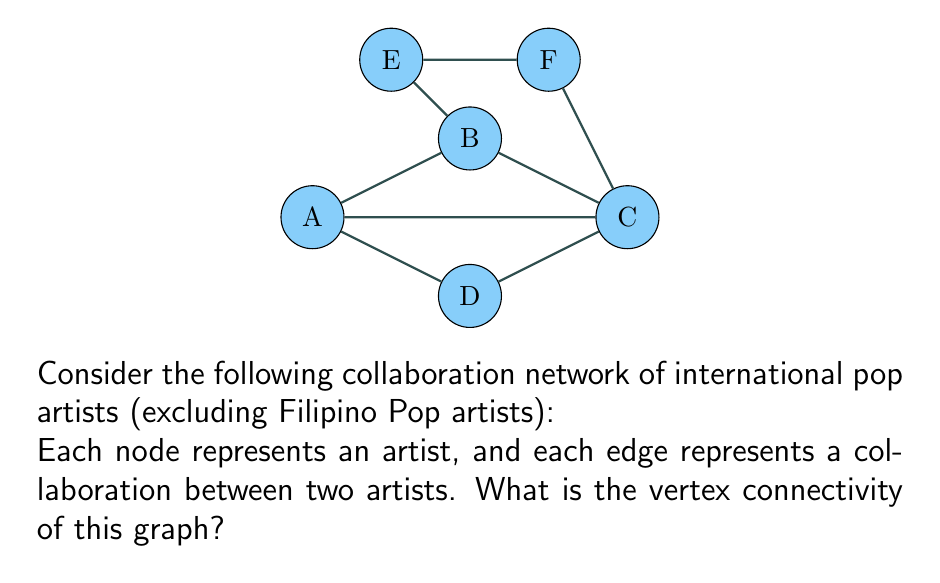Show me your answer to this math problem. To find the vertex connectivity of the graph, we need to determine the minimum number of vertices that need to be removed to disconnect the graph or reduce it to a single vertex.

Step 1: Analyze the graph structure
- The graph has 6 vertices (A, B, C, D, E, F)
- It forms a cycle A-B-C-D-A with additional connections B-E, E-F, F-C, and A-C

Step 2: Consider potential cut-sets
- Removing any single vertex does not disconnect the graph
- Removing vertices B and C disconnects the graph into three components: {A,D}, {E}, and {F}

Step 3: Verify that there is no smaller cut-set
- Removing any single vertex leaves the graph connected
- Any pair of vertices other than B and C does not disconnect the graph as much

Step 4: Define vertex connectivity
The vertex connectivity of a graph, denoted as $\kappa(G)$, is the minimum number of vertices whose removal results in a disconnected graph or a graph with only one vertex.

Step 5: Conclude
Since removing 2 vertices (B and C) is sufficient and necessary to disconnect the graph, the vertex connectivity of this graph is 2.
Answer: $\kappa(G) = 2$ 